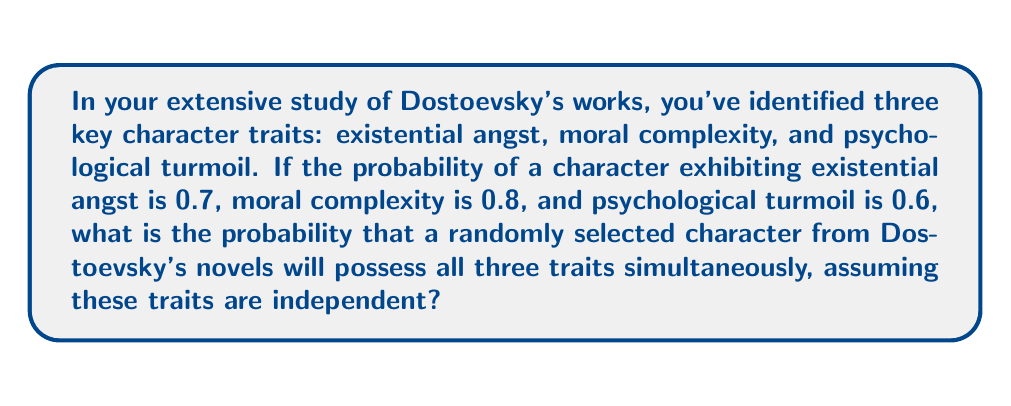Show me your answer to this math problem. To solve this problem, we need to apply the multiplication rule for independent events. Since we're assuming the traits are independent, we can multiply the individual probabilities to find the probability of all three occurring together.

Let's define our events:
A: Character exhibits existential angst (P(A) = 0.7)
B: Character exhibits moral complexity (P(B) = 0.8)
C: Character exhibits psychological turmoil (P(C) = 0.6)

We want to find P(A ∩ B ∩ C), the probability of all three traits occurring simultaneously.

For independent events, P(A ∩ B ∩ C) = P(A) × P(B) × P(C)

Substituting our values:

P(A ∩ B ∩ C) = 0.7 × 0.8 × 0.6

Calculating:
$$P(A ∩ B ∩ C) = 0.7 \times 0.8 \times 0.6 = 0.336$$

Therefore, the probability that a randomly selected character from Dostoevsky's novels will possess all three traits simultaneously is 0.336 or 33.6%.
Answer: 0.336 